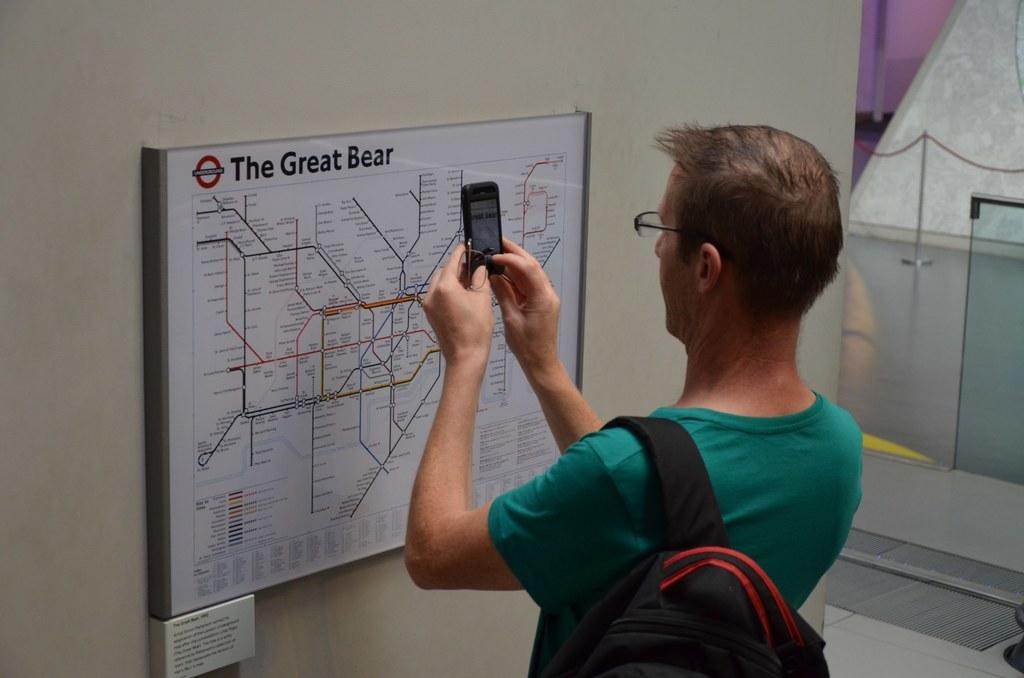Provide a one-sentence caption for the provided image. A man photographs a map of the Great Bear. 